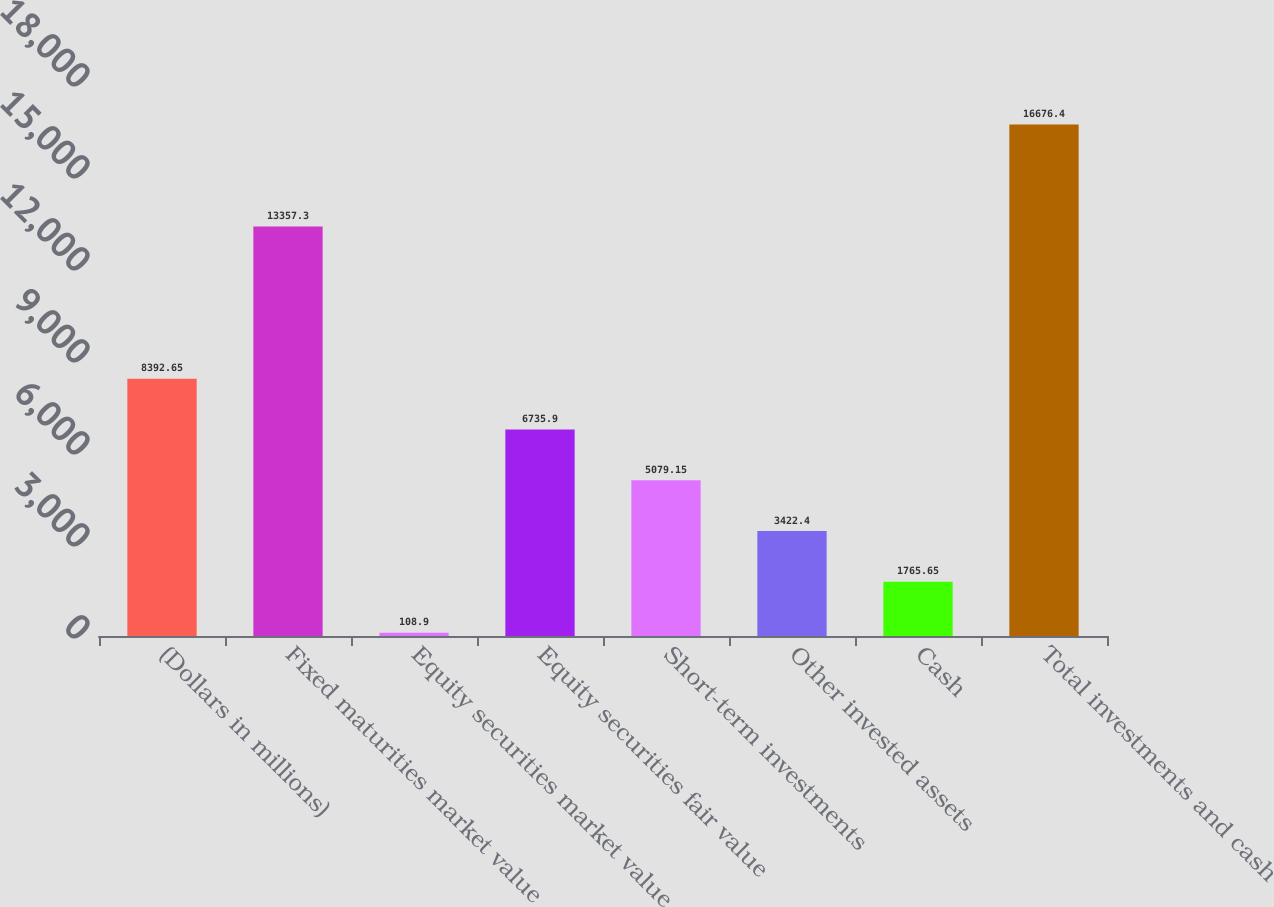<chart> <loc_0><loc_0><loc_500><loc_500><bar_chart><fcel>(Dollars in millions)<fcel>Fixed maturities market value<fcel>Equity securities market value<fcel>Equity securities fair value<fcel>Short-term investments<fcel>Other invested assets<fcel>Cash<fcel>Total investments and cash<nl><fcel>8392.65<fcel>13357.3<fcel>108.9<fcel>6735.9<fcel>5079.15<fcel>3422.4<fcel>1765.65<fcel>16676.4<nl></chart> 